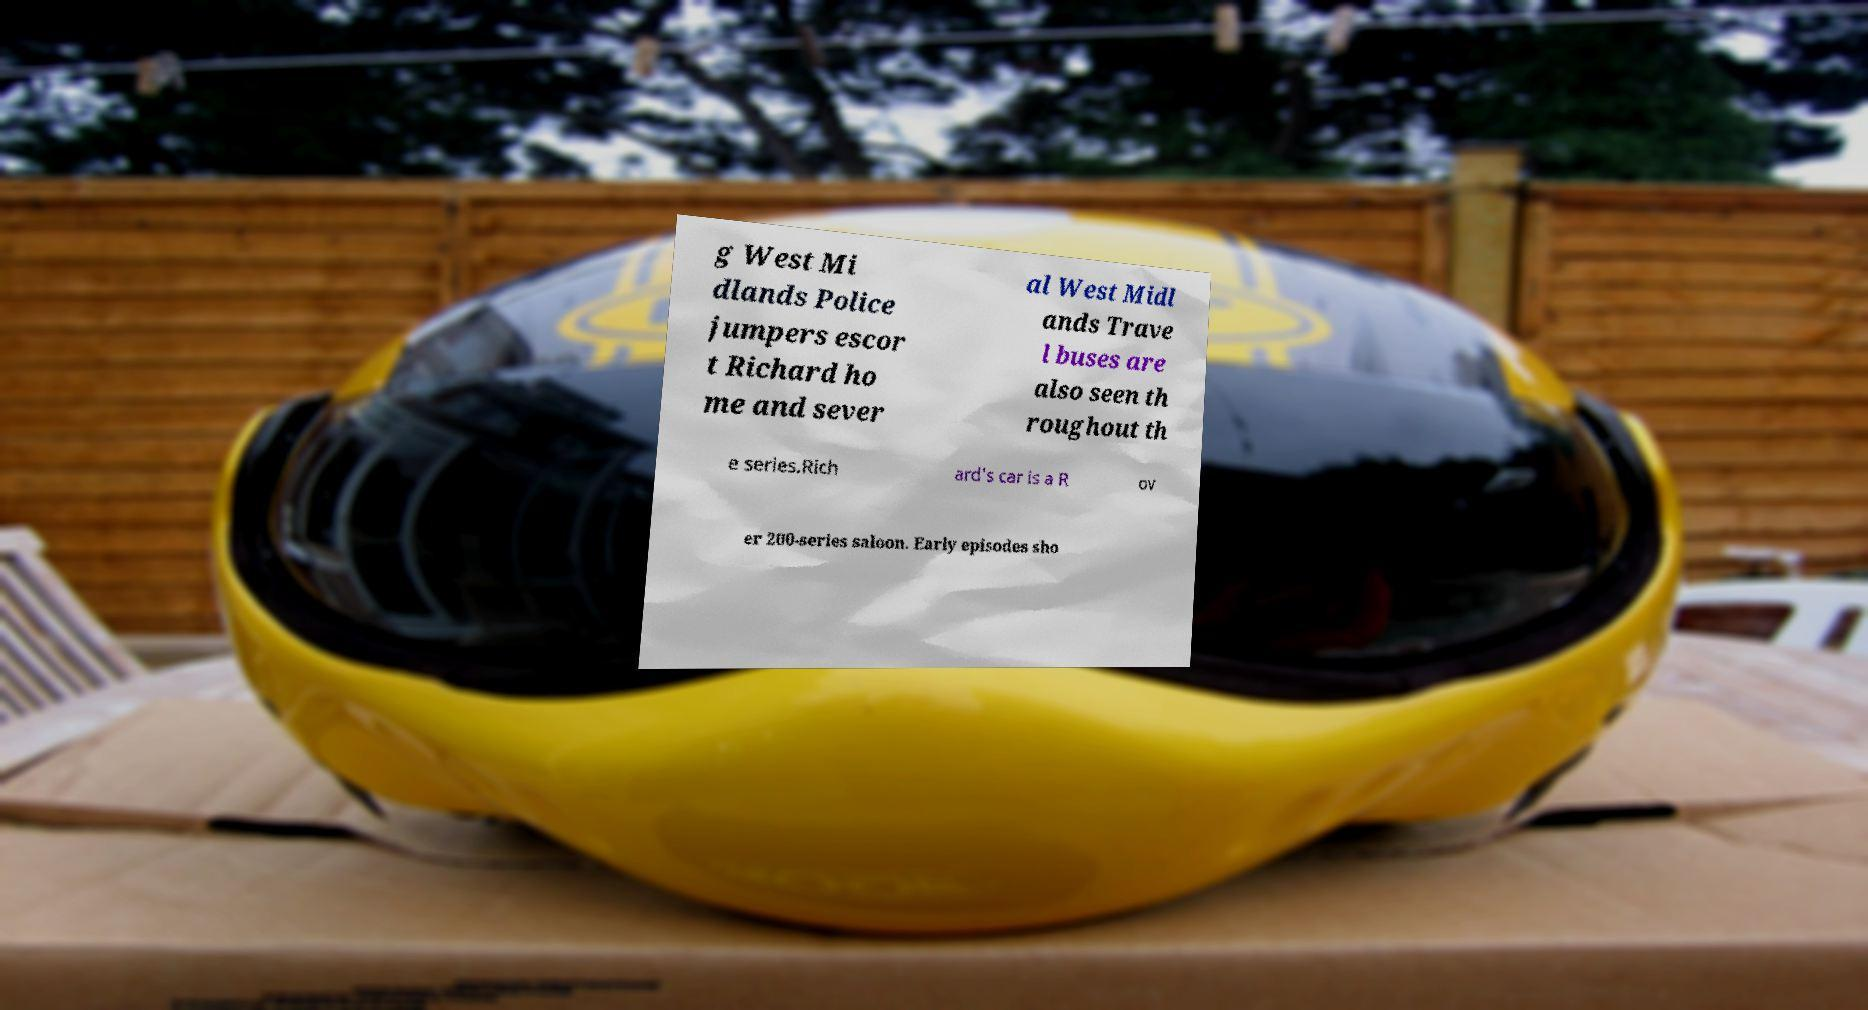There's text embedded in this image that I need extracted. Can you transcribe it verbatim? g West Mi dlands Police jumpers escor t Richard ho me and sever al West Midl ands Trave l buses are also seen th roughout th e series.Rich ard's car is a R ov er 200-series saloon. Early episodes sho 